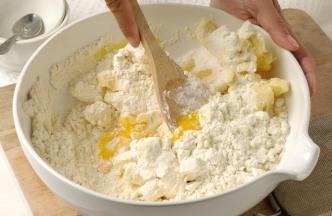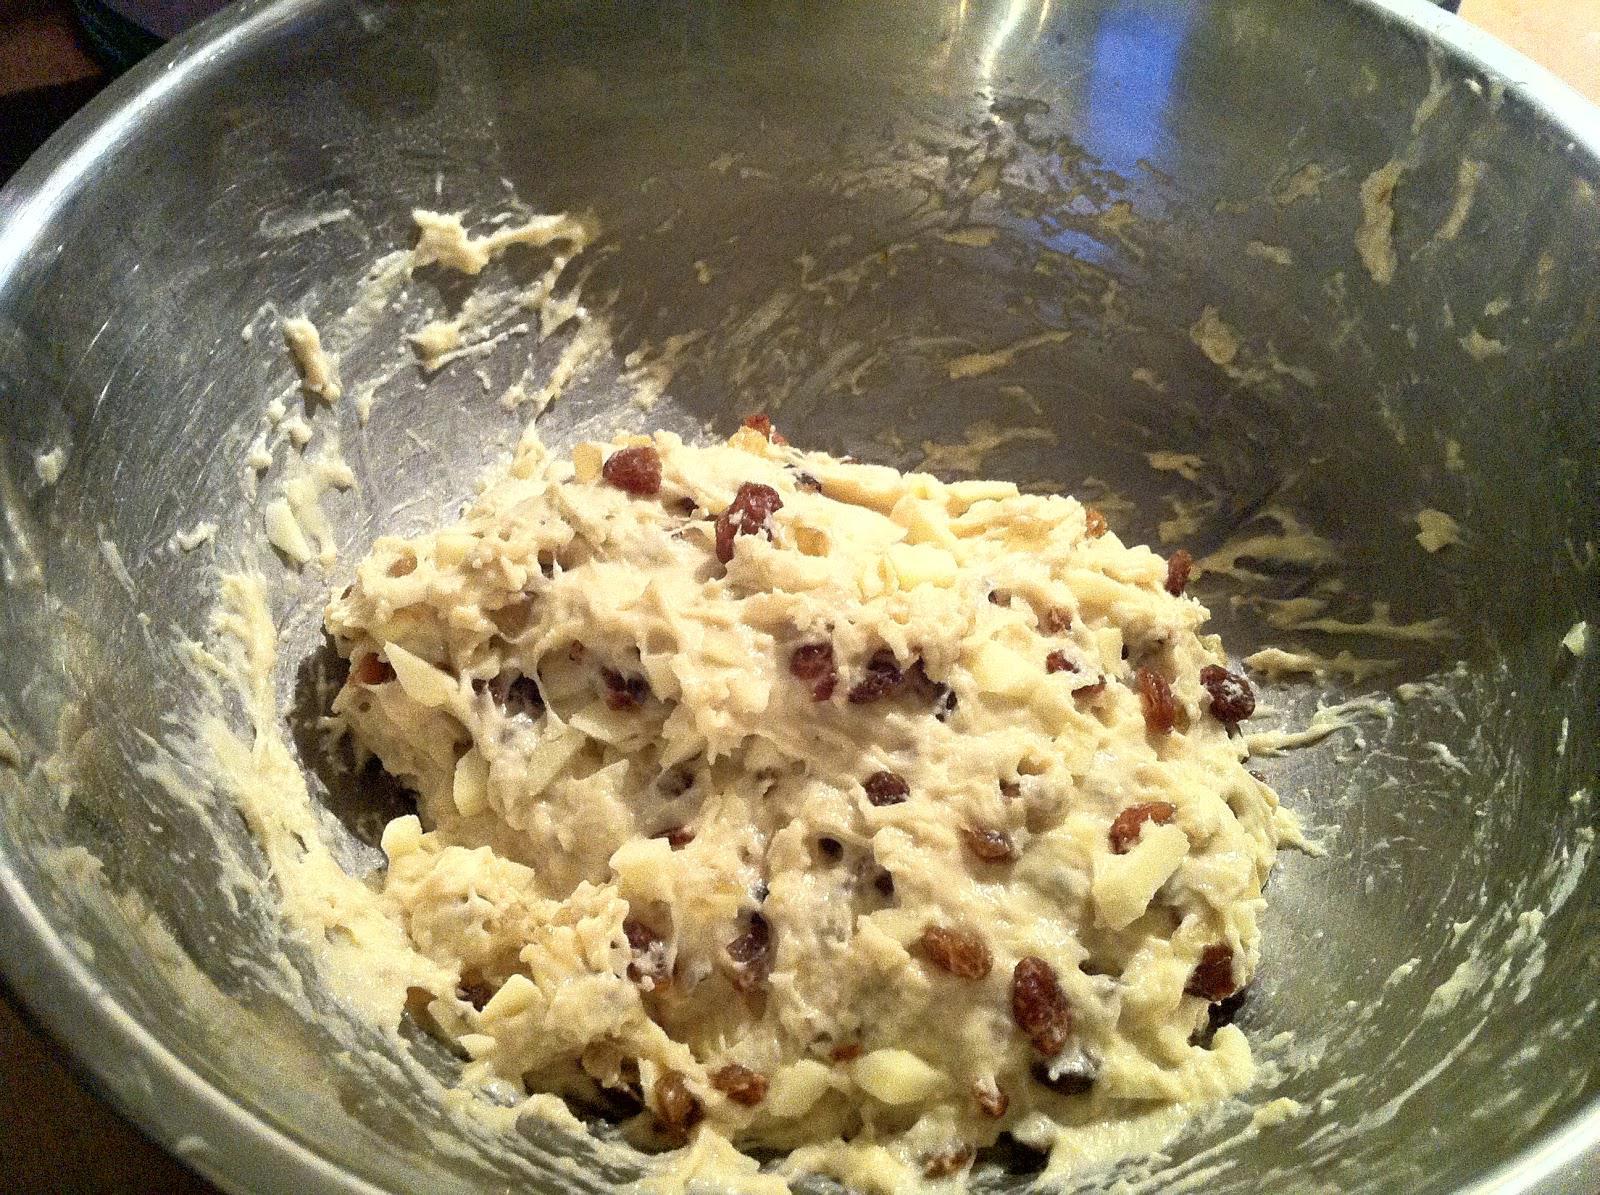The first image is the image on the left, the second image is the image on the right. Considering the images on both sides, is "Each image features a bowl of ingredients, with a utensil in the bowl and its one handle sticking out." valid? Answer yes or no. No. The first image is the image on the left, the second image is the image on the right. Evaluate the accuracy of this statement regarding the images: "One of the images does not contain a handheld utensil.". Is it true? Answer yes or no. Yes. 